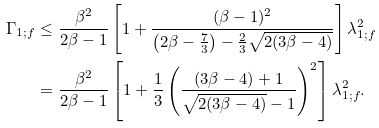Convert formula to latex. <formula><loc_0><loc_0><loc_500><loc_500>\Gamma _ { 1 ; f } & \leq \frac { \beta ^ { 2 } } { 2 \beta - 1 } \left [ 1 + \frac { ( \beta - 1 ) ^ { 2 } } { \left ( 2 \beta - \frac { 7 } { 3 } \right ) - \frac { 2 } { 3 } \sqrt { 2 ( 3 \beta - 4 ) } } \right ] \lambda _ { 1 ; f } ^ { 2 } \\ & = \frac { \beta ^ { 2 } } { 2 \beta - 1 } \left [ 1 + \frac { 1 } { 3 } \left ( \frac { ( 3 \beta - 4 ) + 1 } { \sqrt { 2 ( 3 \beta - 4 ) } - 1 } \right ) ^ { 2 } \right ] \lambda _ { 1 ; f } ^ { 2 } .</formula> 